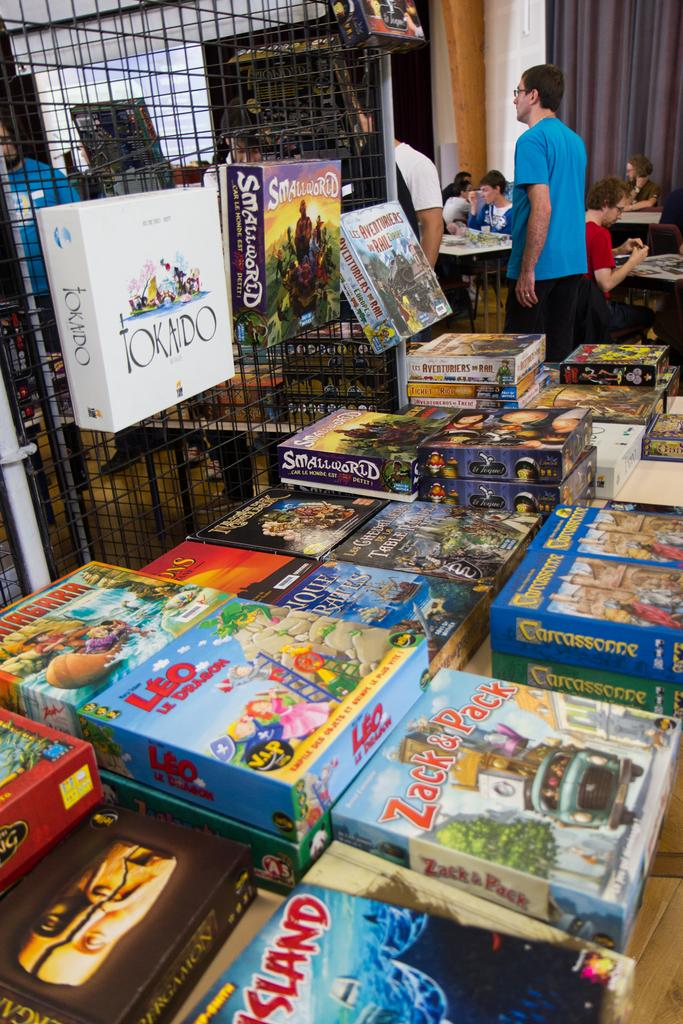<image>
Give a short and clear explanation of the subsequent image. a store with a game that has the name Zack on it 